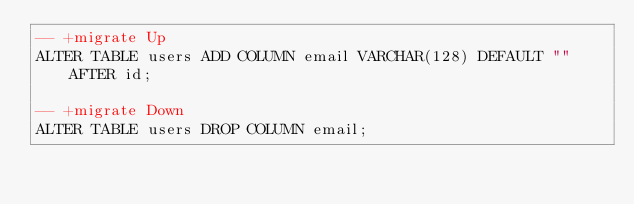<code> <loc_0><loc_0><loc_500><loc_500><_SQL_>-- +migrate Up
ALTER TABLE users ADD COLUMN email VARCHAR(128) DEFAULT "" AFTER id;

-- +migrate Down
ALTER TABLE users DROP COLUMN email;
</code> 